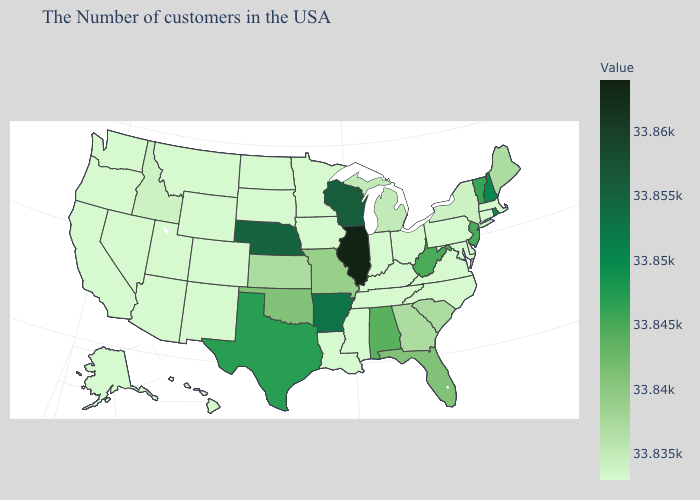Does South Dakota have a higher value than New Jersey?
Concise answer only. No. Does Connecticut have the highest value in the USA?
Concise answer only. No. Among the states that border Minnesota , does Wisconsin have the highest value?
Write a very short answer. Yes. Does South Carolina have a lower value than Maryland?
Answer briefly. No. Which states have the lowest value in the USA?
Concise answer only. Massachusetts, Connecticut, Delaware, Maryland, Pennsylvania, Virginia, North Carolina, Ohio, Kentucky, Indiana, Tennessee, Mississippi, Louisiana, Minnesota, Iowa, South Dakota, North Dakota, Wyoming, Colorado, New Mexico, Utah, Montana, Arizona, Nevada, California, Washington, Oregon, Alaska, Hawaii. 